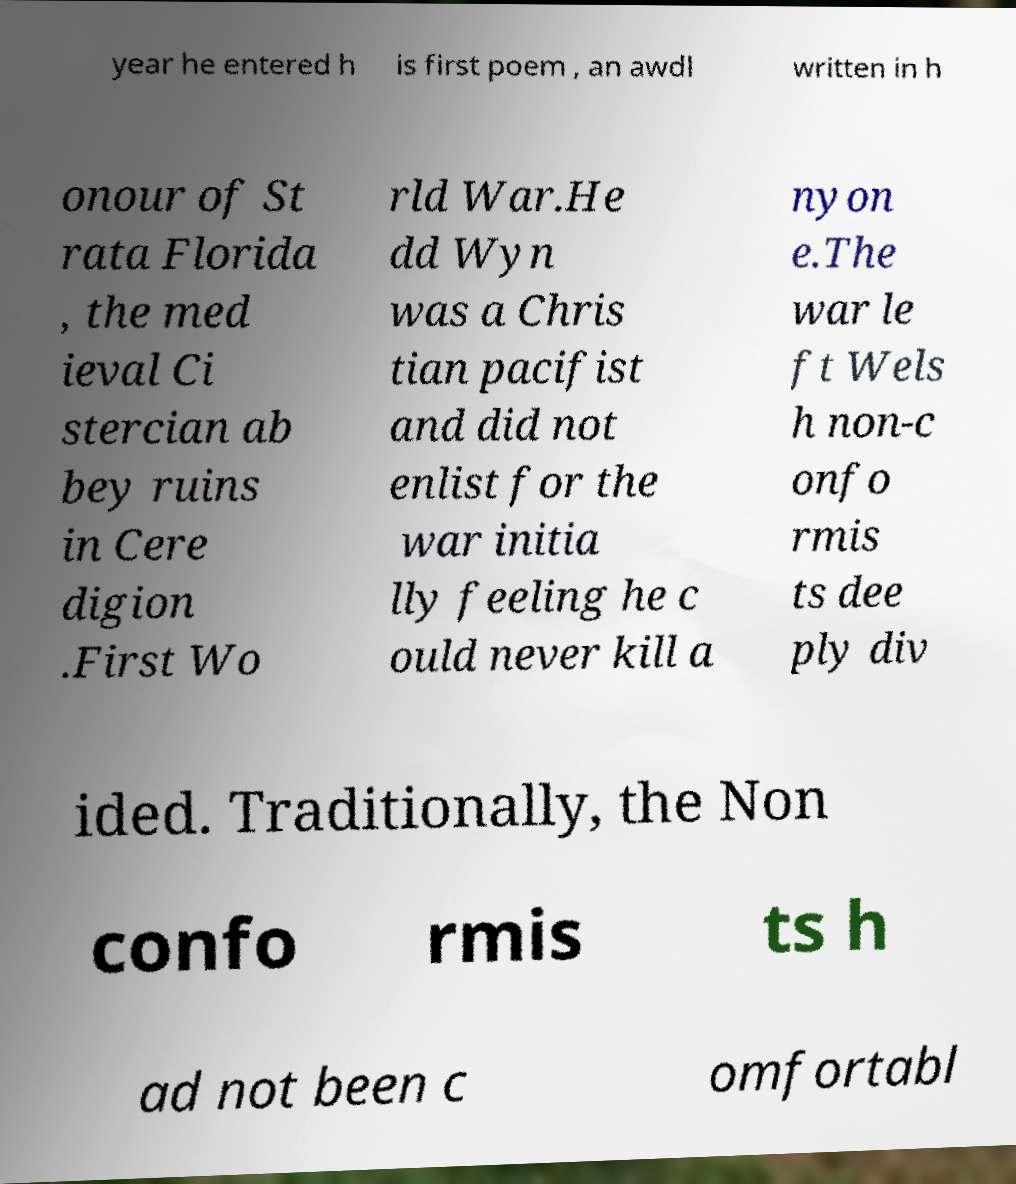I need the written content from this picture converted into text. Can you do that? year he entered h is first poem , an awdl written in h onour of St rata Florida , the med ieval Ci stercian ab bey ruins in Cere digion .First Wo rld War.He dd Wyn was a Chris tian pacifist and did not enlist for the war initia lly feeling he c ould never kill a nyon e.The war le ft Wels h non-c onfo rmis ts dee ply div ided. Traditionally, the Non confo rmis ts h ad not been c omfortabl 